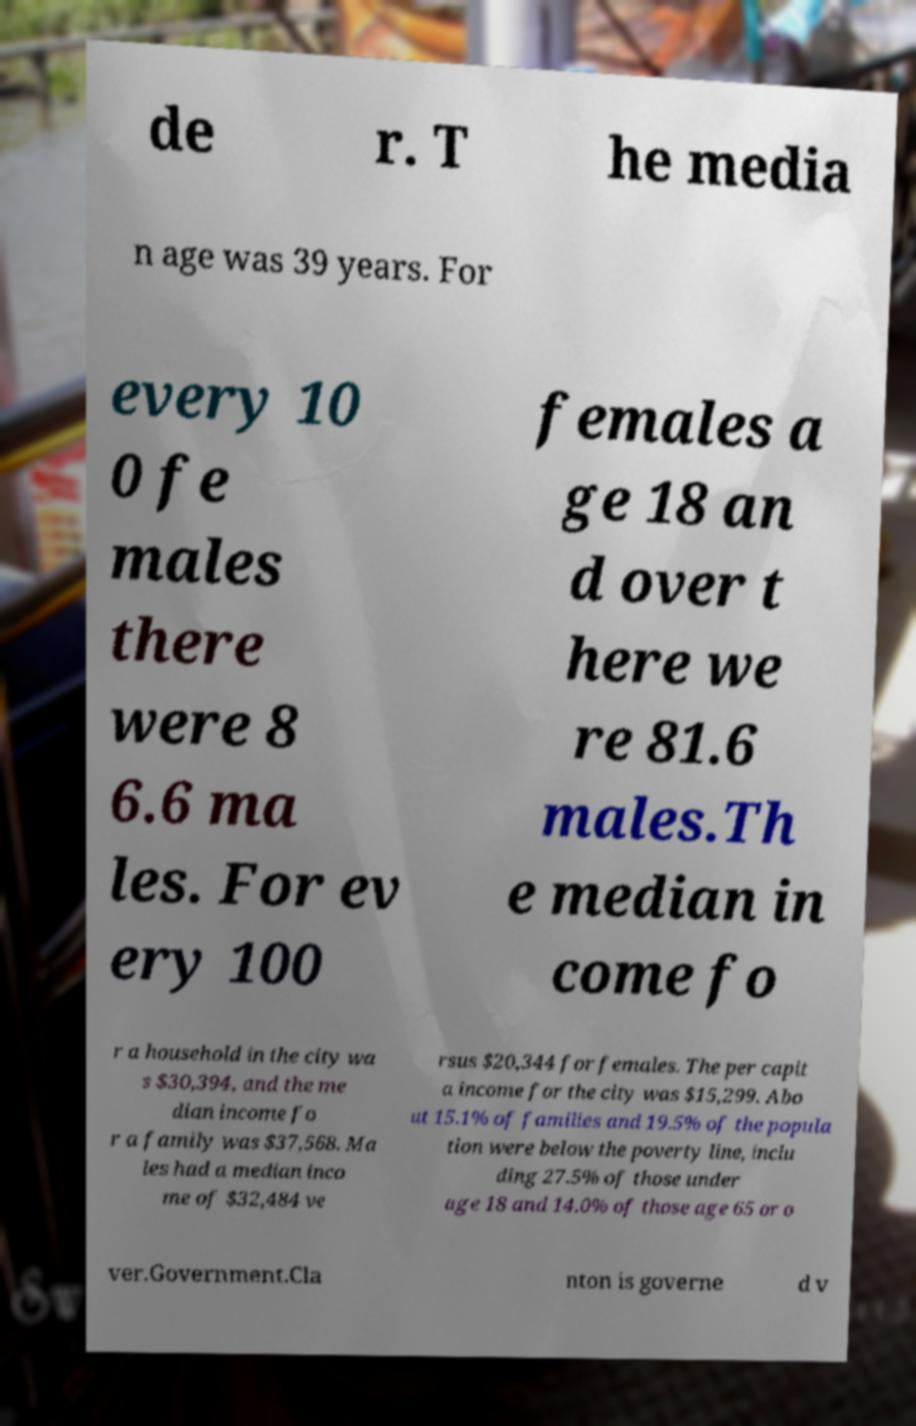Could you assist in decoding the text presented in this image and type it out clearly? de r. T he media n age was 39 years. For every 10 0 fe males there were 8 6.6 ma les. For ev ery 100 females a ge 18 an d over t here we re 81.6 males.Th e median in come fo r a household in the city wa s $30,394, and the me dian income fo r a family was $37,568. Ma les had a median inco me of $32,484 ve rsus $20,344 for females. The per capit a income for the city was $15,299. Abo ut 15.1% of families and 19.5% of the popula tion were below the poverty line, inclu ding 27.5% of those under age 18 and 14.0% of those age 65 or o ver.Government.Cla nton is governe d v 